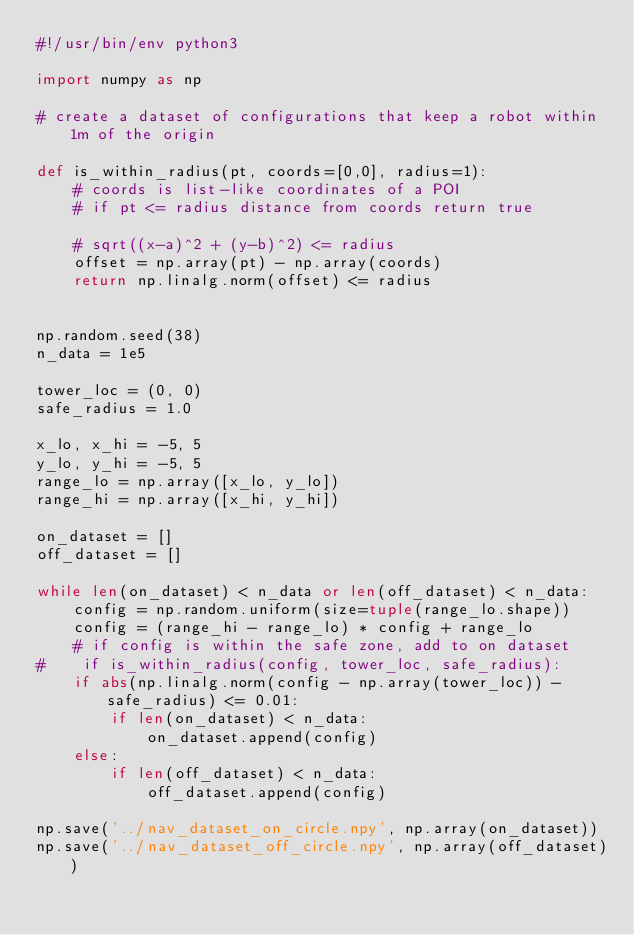<code> <loc_0><loc_0><loc_500><loc_500><_Python_>#!/usr/bin/env python3 

import numpy as np

# create a dataset of configurations that keep a robot within 1m of the origin

def is_within_radius(pt, coords=[0,0], radius=1): 
    # coords is list-like coordinates of a POI
    # if pt <= radius distance from coords return true
    
    # sqrt((x-a)^2 + (y-b)^2) <= radius 
    offset = np.array(pt) - np.array(coords)
    return np.linalg.norm(offset) <= radius


np.random.seed(38)
n_data = 1e5

tower_loc = (0, 0)
safe_radius = 1.0

x_lo, x_hi = -5, 5
y_lo, y_hi = -5, 5
range_lo = np.array([x_lo, y_lo])
range_hi = np.array([x_hi, y_hi])

on_dataset = []
off_dataset = []

while len(on_dataset) < n_data or len(off_dataset) < n_data:
    config = np.random.uniform(size=tuple(range_lo.shape))
    config = (range_hi - range_lo) * config + range_lo 
    # if config is within the safe zone, add to on dataset
#    if is_within_radius(config, tower_loc, safe_radius):
    if abs(np.linalg.norm(config - np.array(tower_loc)) - safe_radius) <= 0.01: 
        if len(on_dataset) < n_data:
            on_dataset.append(config)
    else: 
        if len(off_dataset) < n_data:
            off_dataset.append(config)

np.save('../nav_dataset_on_circle.npy', np.array(on_dataset))
np.save('../nav_dataset_off_circle.npy', np.array(off_dataset))
</code> 